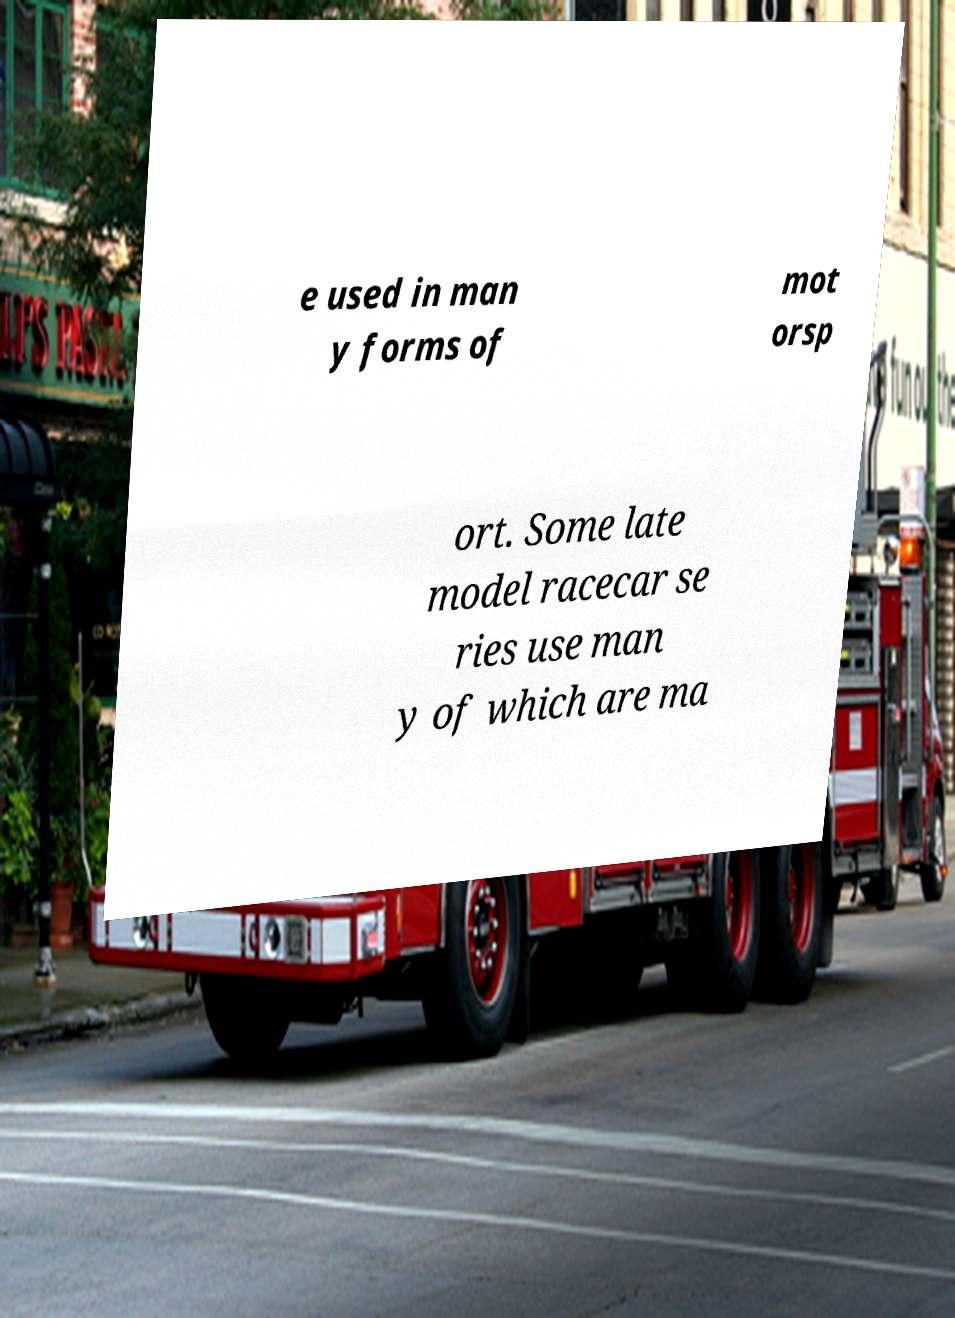Could you extract and type out the text from this image? e used in man y forms of mot orsp ort. Some late model racecar se ries use man y of which are ma 